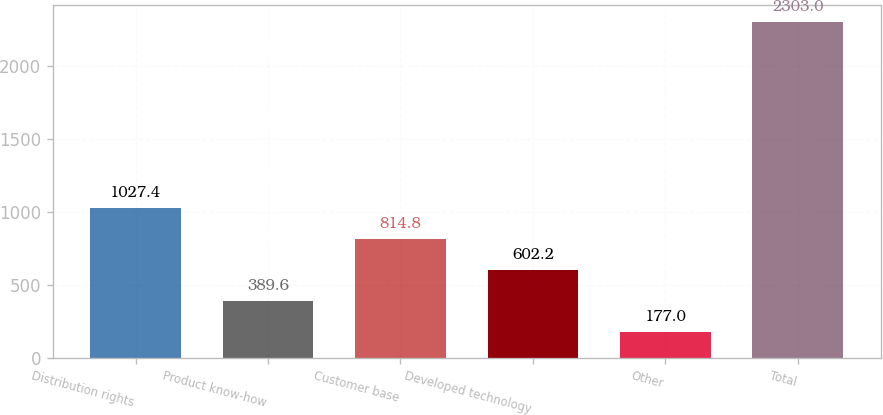<chart> <loc_0><loc_0><loc_500><loc_500><bar_chart><fcel>Distribution rights<fcel>Product know-how<fcel>Customer base<fcel>Developed technology<fcel>Other<fcel>Total<nl><fcel>1027.4<fcel>389.6<fcel>814.8<fcel>602.2<fcel>177<fcel>2303<nl></chart> 